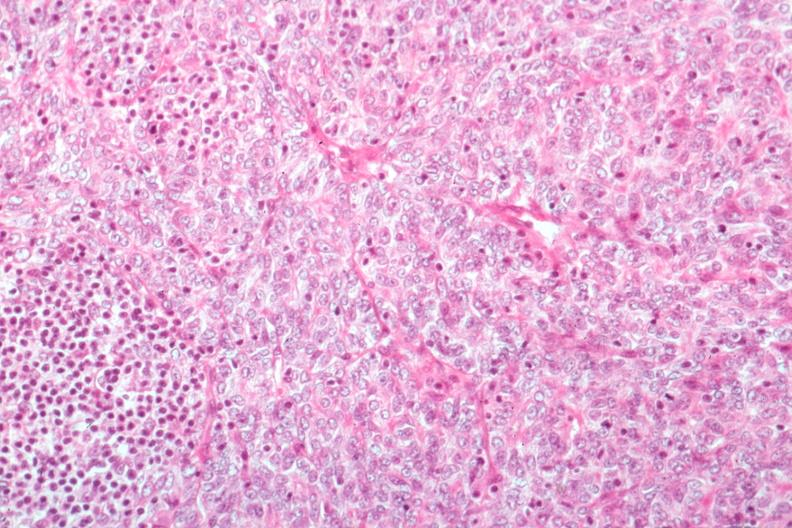s hematologic present?
Answer the question using a single word or phrase. Yes 